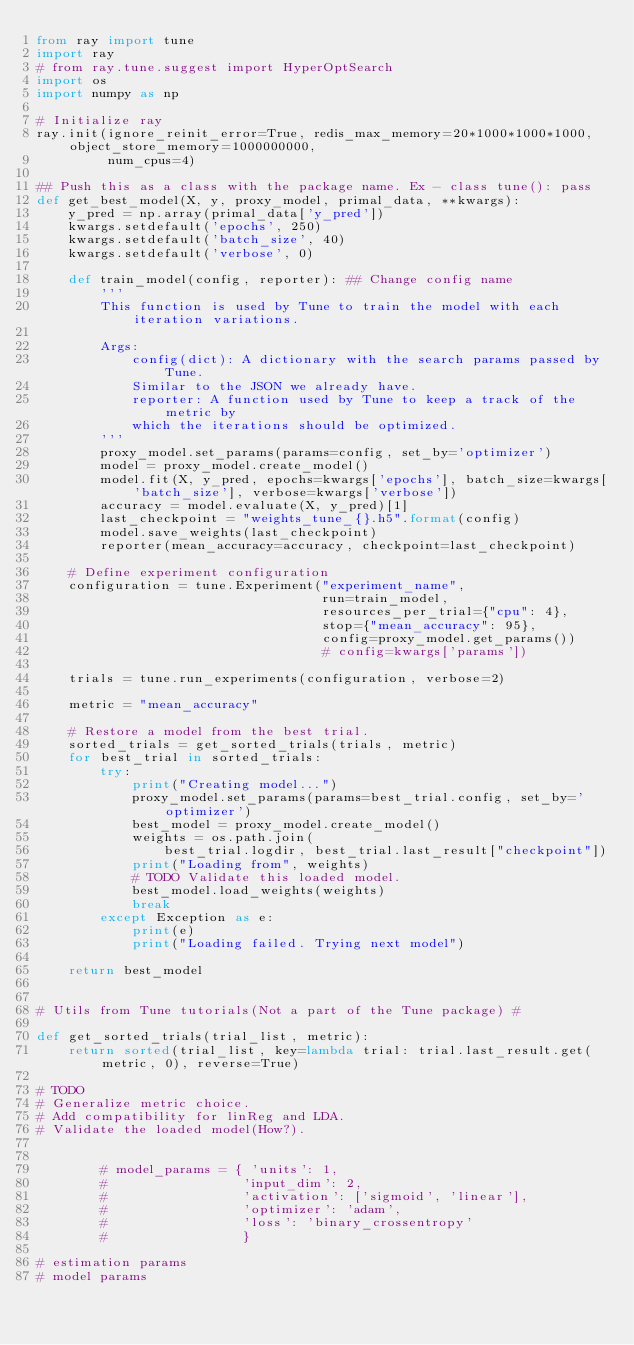<code> <loc_0><loc_0><loc_500><loc_500><_Python_>from ray import tune
import ray
# from ray.tune.suggest import HyperOptSearch
import os
import numpy as np

# Initialize ray
ray.init(ignore_reinit_error=True, redis_max_memory=20*1000*1000*1000, object_store_memory=1000000000,
         num_cpus=4)

## Push this as a class with the package name. Ex - class tune(): pass
def get_best_model(X, y, proxy_model, primal_data, **kwargs):
    y_pred = np.array(primal_data['y_pred'])
    kwargs.setdefault('epochs', 250)
    kwargs.setdefault('batch_size', 40)
    kwargs.setdefault('verbose', 0)

    def train_model(config, reporter): ## Change config name
        '''
        This function is used by Tune to train the model with each iteration variations.

        Args:
            config(dict): A dictionary with the search params passed by Tune.
            Similar to the JSON we already have.
            reporter: A function used by Tune to keep a track of the metric by
            which the iterations should be optimized.
        '''
        proxy_model.set_params(params=config, set_by='optimizer')
        model = proxy_model.create_model()
        model.fit(X, y_pred, epochs=kwargs['epochs'], batch_size=kwargs['batch_size'], verbose=kwargs['verbose'])
        accuracy = model.evaluate(X, y_pred)[1]
        last_checkpoint = "weights_tune_{}.h5".format(config)
        model.save_weights(last_checkpoint)
        reporter(mean_accuracy=accuracy, checkpoint=last_checkpoint)

    # Define experiment configuration
    configuration = tune.Experiment("experiment_name",
                                    run=train_model,
                                    resources_per_trial={"cpu": 4},
                                    stop={"mean_accuracy": 95},
                                    config=proxy_model.get_params())
                                    # config=kwargs['params'])

    trials = tune.run_experiments(configuration, verbose=2)

    metric = "mean_accuracy"

    # Restore a model from the best trial.
    sorted_trials = get_sorted_trials(trials, metric)
    for best_trial in sorted_trials:
        try:
            print("Creating model...")
            proxy_model.set_params(params=best_trial.config, set_by='optimizer')
            best_model = proxy_model.create_model()
            weights = os.path.join(
                best_trial.logdir, best_trial.last_result["checkpoint"])
            print("Loading from", weights)
            # TODO Validate this loaded model.
            best_model.load_weights(weights)
            break
        except Exception as e:
            print(e)
            print("Loading failed. Trying next model")

    return best_model


# Utils from Tune tutorials(Not a part of the Tune package) #

def get_sorted_trials(trial_list, metric):
    return sorted(trial_list, key=lambda trial: trial.last_result.get(metric, 0), reverse=True)

# TODO
# Generalize metric choice.
# Add compatibility for linReg and LDA.
# Validate the loaded model(How?).


        # model_params = { 'units': 1,
        #                 'input_dim': 2,
        #                 'activation': ['sigmoid', 'linear'],
        #                 'optimizer': 'adam',
        #                 'loss': 'binary_crossentropy'
        #                 }

# estimation params
# model params
</code> 